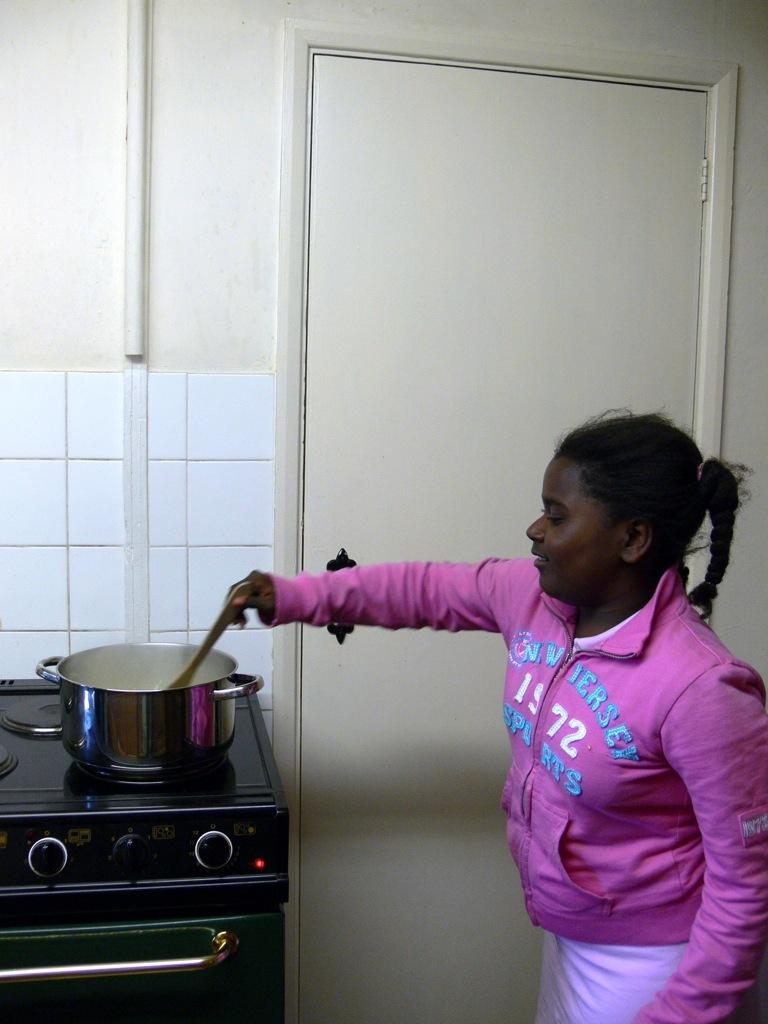Provide a one-sentence caption for the provided image. a little girl stirring a pot in a  pink sweater that says 'new jersey'. 